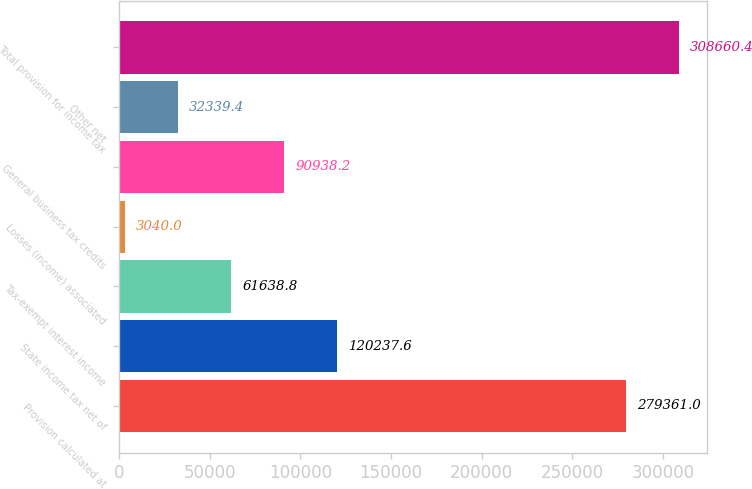Convert chart. <chart><loc_0><loc_0><loc_500><loc_500><bar_chart><fcel>Provision calculated at<fcel>State income tax net of<fcel>Tax-exempt interest income<fcel>Losses (income) associated<fcel>General business tax credits<fcel>Other net<fcel>Total provision for income tax<nl><fcel>279361<fcel>120238<fcel>61638.8<fcel>3040<fcel>90938.2<fcel>32339.4<fcel>308660<nl></chart> 